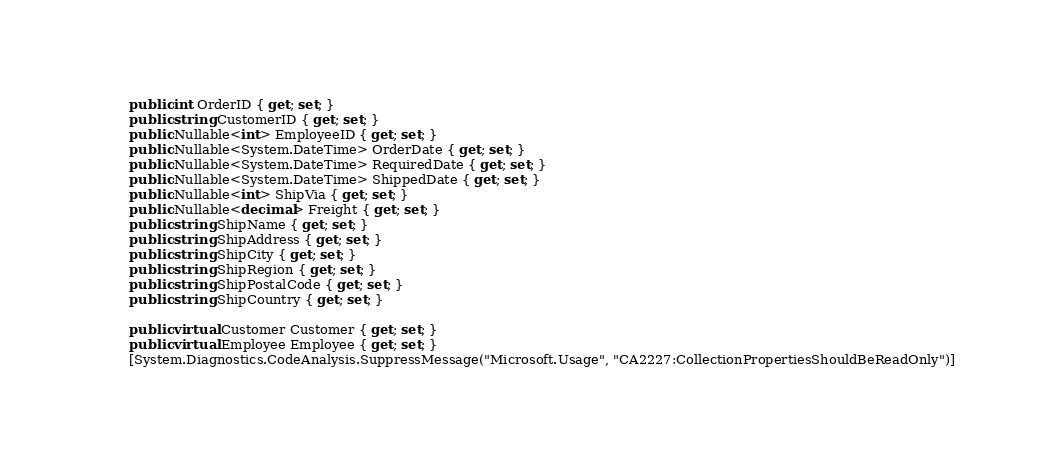Convert code to text. <code><loc_0><loc_0><loc_500><loc_500><_C#_>        public int OrderID { get; set; }
        public string CustomerID { get; set; }
        public Nullable<int> EmployeeID { get; set; }
        public Nullable<System.DateTime> OrderDate { get; set; }
        public Nullable<System.DateTime> RequiredDate { get; set; }
        public Nullable<System.DateTime> ShippedDate { get; set; }
        public Nullable<int> ShipVia { get; set; }
        public Nullable<decimal> Freight { get; set; }
        public string ShipName { get; set; }
        public string ShipAddress { get; set; }
        public string ShipCity { get; set; }
        public string ShipRegion { get; set; }
        public string ShipPostalCode { get; set; }
        public string ShipCountry { get; set; }
    
        public virtual Customer Customer { get; set; }
        public virtual Employee Employee { get; set; }
        [System.Diagnostics.CodeAnalysis.SuppressMessage("Microsoft.Usage", "CA2227:CollectionPropertiesShouldBeReadOnly")]</code> 